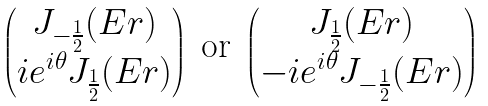<formula> <loc_0><loc_0><loc_500><loc_500>\begin{pmatrix} J _ { - \frac { 1 } { 2 } } ( E r ) \\ i e ^ { i \theta } J _ { \frac { 1 } { 2 } } ( E r ) \end{pmatrix} \text { or } \begin{pmatrix} J _ { \frac { 1 } { 2 } } ( E r ) \\ - i e ^ { i \theta } J _ { - \frac { 1 } { 2 } } ( E r ) \end{pmatrix}</formula> 